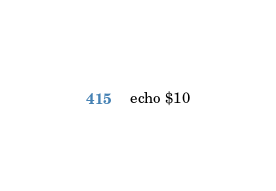<code> <loc_0><loc_0><loc_500><loc_500><_Bash_>echo $10</code> 